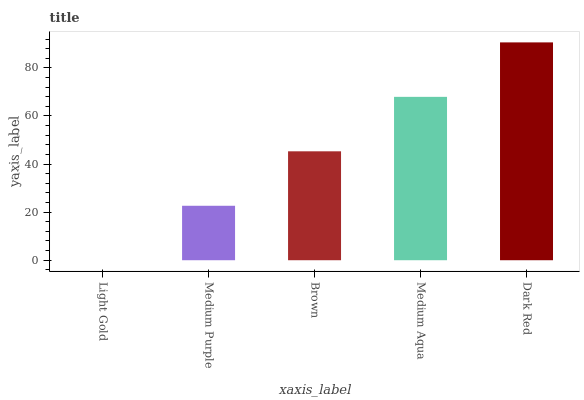Is Light Gold the minimum?
Answer yes or no. Yes. Is Dark Red the maximum?
Answer yes or no. Yes. Is Medium Purple the minimum?
Answer yes or no. No. Is Medium Purple the maximum?
Answer yes or no. No. Is Medium Purple greater than Light Gold?
Answer yes or no. Yes. Is Light Gold less than Medium Purple?
Answer yes or no. Yes. Is Light Gold greater than Medium Purple?
Answer yes or no. No. Is Medium Purple less than Light Gold?
Answer yes or no. No. Is Brown the high median?
Answer yes or no. Yes. Is Brown the low median?
Answer yes or no. Yes. Is Light Gold the high median?
Answer yes or no. No. Is Medium Aqua the low median?
Answer yes or no. No. 